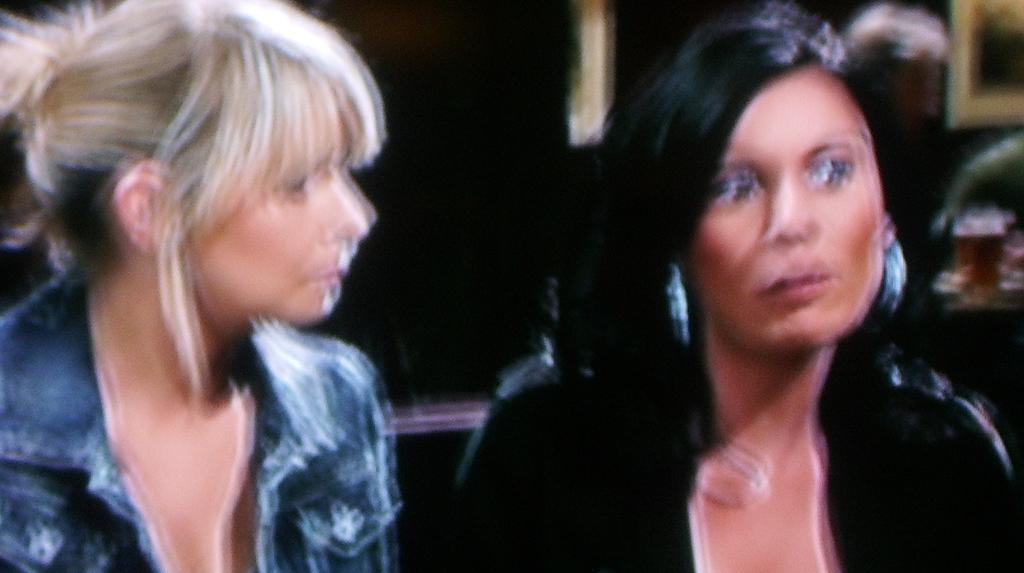How many people are present in the image? There are two ladies in the image. What type of thumb can be seen on the curtain in the image? There is no thumb or curtain present in the image; it only features two ladies. 